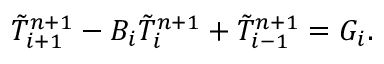Convert formula to latex. <formula><loc_0><loc_0><loc_500><loc_500>\tilde { T } _ { i + 1 } ^ { n + 1 } - { B _ { i } } \tilde { T } _ { i } ^ { n + 1 } + \tilde { T } _ { i - 1 } ^ { n + 1 } = { G _ { i } } .</formula> 